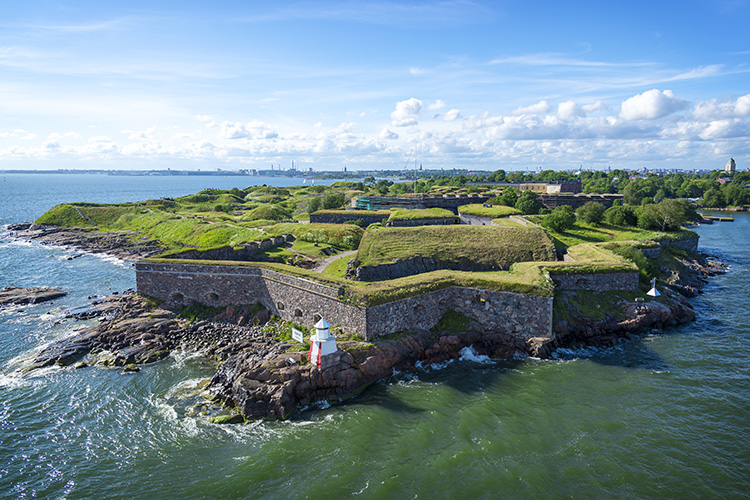What are the key elements in this picture? The image magnificently captures the Suomenlinna Fortress, a distinctive historical marvel in Helsinki, Finland, set against the backdrop of the modern city skyline. The fortress, sprawling across several islands, is defined by robust stone walls and verdant grass, symbolizing resilience and natural beauty. The calm waters surrounding the fortress mirror the sky, adding a serene quality to the scene. The panoramic view not only highlights the architectural might and strategic layout of the fortress but also subtly hints at its role as a bridge between the old and the contemporary urban landscape visible in the distance. Exploring this fortress offers a journey through history, architecture, and stunning natural vistas. 